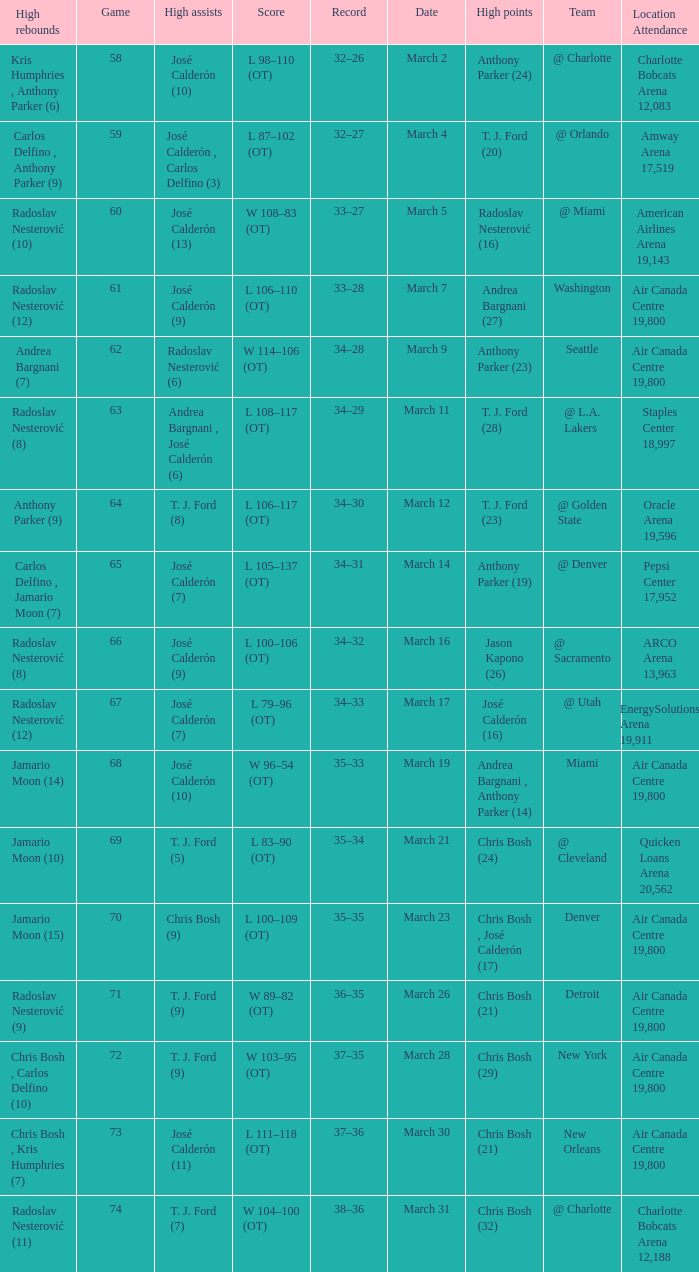How many attended the game on march 16 after over 64 games? ARCO Arena 13,963. Write the full table. {'header': ['High rebounds', 'Game', 'High assists', 'Score', 'Record', 'Date', 'High points', 'Team', 'Location Attendance'], 'rows': [['Kris Humphries , Anthony Parker (6)', '58', 'José Calderón (10)', 'L 98–110 (OT)', '32–26', 'March 2', 'Anthony Parker (24)', '@ Charlotte', 'Charlotte Bobcats Arena 12,083'], ['Carlos Delfino , Anthony Parker (9)', '59', 'José Calderón , Carlos Delfino (3)', 'L 87–102 (OT)', '32–27', 'March 4', 'T. J. Ford (20)', '@ Orlando', 'Amway Arena 17,519'], ['Radoslav Nesterović (10)', '60', 'José Calderón (13)', 'W 108–83 (OT)', '33–27', 'March 5', 'Radoslav Nesterović (16)', '@ Miami', 'American Airlines Arena 19,143'], ['Radoslav Nesterović (12)', '61', 'José Calderón (9)', 'L 106–110 (OT)', '33–28', 'March 7', 'Andrea Bargnani (27)', 'Washington', 'Air Canada Centre 19,800'], ['Andrea Bargnani (7)', '62', 'Radoslav Nesterović (6)', 'W 114–106 (OT)', '34–28', 'March 9', 'Anthony Parker (23)', 'Seattle', 'Air Canada Centre 19,800'], ['Radoslav Nesterović (8)', '63', 'Andrea Bargnani , José Calderón (6)', 'L 108–117 (OT)', '34–29', 'March 11', 'T. J. Ford (28)', '@ L.A. Lakers', 'Staples Center 18,997'], ['Anthony Parker (9)', '64', 'T. J. Ford (8)', 'L 106–117 (OT)', '34–30', 'March 12', 'T. J. Ford (23)', '@ Golden State', 'Oracle Arena 19,596'], ['Carlos Delfino , Jamario Moon (7)', '65', 'José Calderón (7)', 'L 105–137 (OT)', '34–31', 'March 14', 'Anthony Parker (19)', '@ Denver', 'Pepsi Center 17,952'], ['Radoslav Nesterović (8)', '66', 'José Calderón (9)', 'L 100–106 (OT)', '34–32', 'March 16', 'Jason Kapono (26)', '@ Sacramento', 'ARCO Arena 13,963'], ['Radoslav Nesterović (12)', '67', 'José Calderón (7)', 'L 79–96 (OT)', '34–33', 'March 17', 'José Calderón (16)', '@ Utah', 'EnergySolutions Arena 19,911'], ['Jamario Moon (14)', '68', 'José Calderón (10)', 'W 96–54 (OT)', '35–33', 'March 19', 'Andrea Bargnani , Anthony Parker (14)', 'Miami', 'Air Canada Centre 19,800'], ['Jamario Moon (10)', '69', 'T. J. Ford (5)', 'L 83–90 (OT)', '35–34', 'March 21', 'Chris Bosh (24)', '@ Cleveland', 'Quicken Loans Arena 20,562'], ['Jamario Moon (15)', '70', 'Chris Bosh (9)', 'L 100–109 (OT)', '35–35', 'March 23', 'Chris Bosh , José Calderón (17)', 'Denver', 'Air Canada Centre 19,800'], ['Radoslav Nesterović (9)', '71', 'T. J. Ford (9)', 'W 89–82 (OT)', '36–35', 'March 26', 'Chris Bosh (21)', 'Detroit', 'Air Canada Centre 19,800'], ['Chris Bosh , Carlos Delfino (10)', '72', 'T. J. Ford (9)', 'W 103–95 (OT)', '37–35', 'March 28', 'Chris Bosh (29)', 'New York', 'Air Canada Centre 19,800'], ['Chris Bosh , Kris Humphries (7)', '73', 'José Calderón (11)', 'L 111–118 (OT)', '37–36', 'March 30', 'Chris Bosh (21)', 'New Orleans', 'Air Canada Centre 19,800'], ['Radoslav Nesterović (11)', '74', 'T. J. Ford (7)', 'W 104–100 (OT)', '38–36', 'March 31', 'Chris Bosh (32)', '@ Charlotte', 'Charlotte Bobcats Arena 12,188']]} 